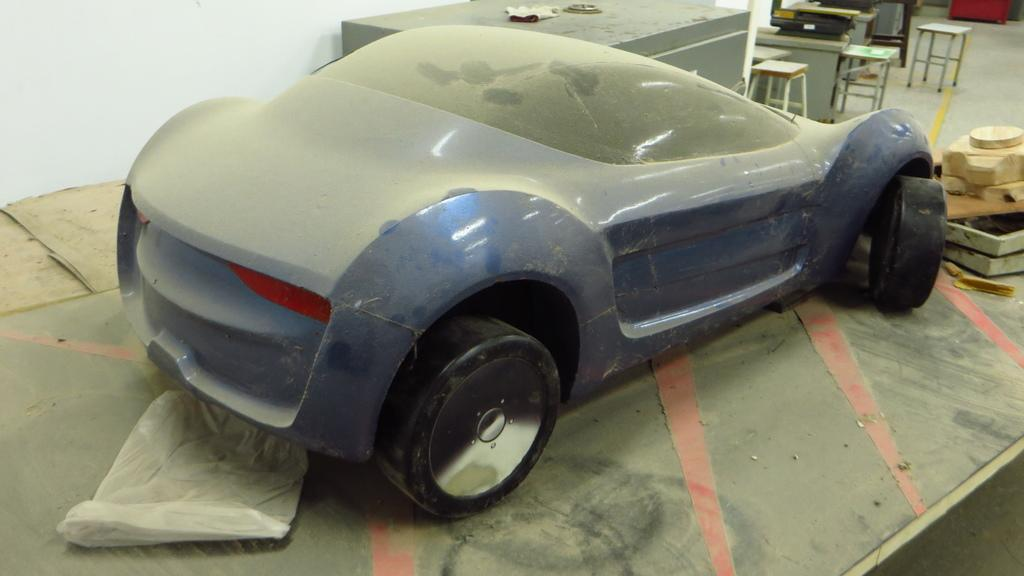What color is the car in the image? The car in the image is blue. What type of pleasure can be seen enjoying a ride in the blue car in the image? There is no indication of pleasure or any passengers in the image; it only shows a blue car. 